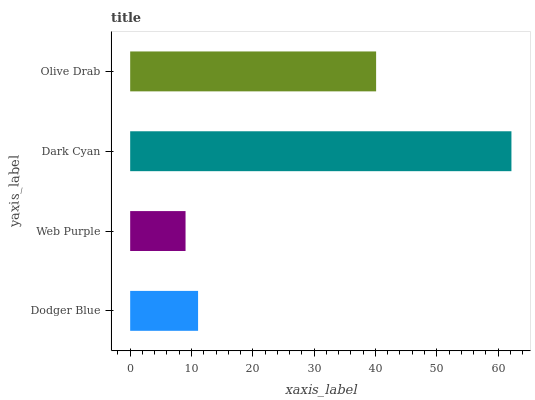Is Web Purple the minimum?
Answer yes or no. Yes. Is Dark Cyan the maximum?
Answer yes or no. Yes. Is Dark Cyan the minimum?
Answer yes or no. No. Is Web Purple the maximum?
Answer yes or no. No. Is Dark Cyan greater than Web Purple?
Answer yes or no. Yes. Is Web Purple less than Dark Cyan?
Answer yes or no. Yes. Is Web Purple greater than Dark Cyan?
Answer yes or no. No. Is Dark Cyan less than Web Purple?
Answer yes or no. No. Is Olive Drab the high median?
Answer yes or no. Yes. Is Dodger Blue the low median?
Answer yes or no. Yes. Is Dodger Blue the high median?
Answer yes or no. No. Is Olive Drab the low median?
Answer yes or no. No. 